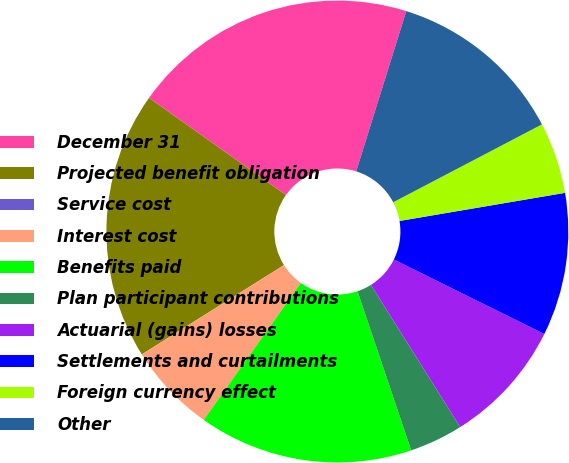Convert chart to OTSL. <chart><loc_0><loc_0><loc_500><loc_500><pie_chart><fcel>December 31<fcel>Projected benefit obligation<fcel>Service cost<fcel>Interest cost<fcel>Benefits paid<fcel>Plan participant contributions<fcel>Actuarial (gains) losses<fcel>Settlements and curtailments<fcel>Foreign currency effect<fcel>Other<nl><fcel>20.0%<fcel>18.75%<fcel>0.0%<fcel>6.25%<fcel>15.0%<fcel>3.75%<fcel>8.75%<fcel>10.0%<fcel>5.0%<fcel>12.5%<nl></chart> 